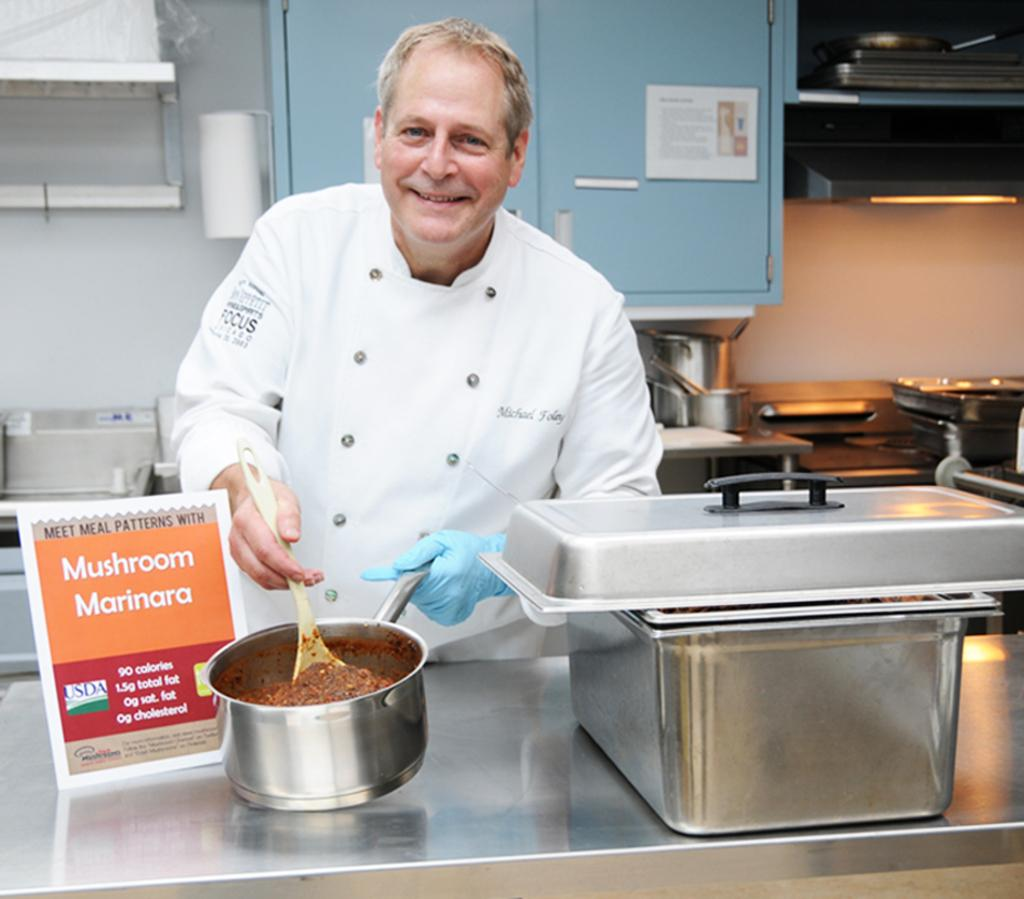<image>
Relay a brief, clear account of the picture shown. A chef making a meal of mushroom marinara 